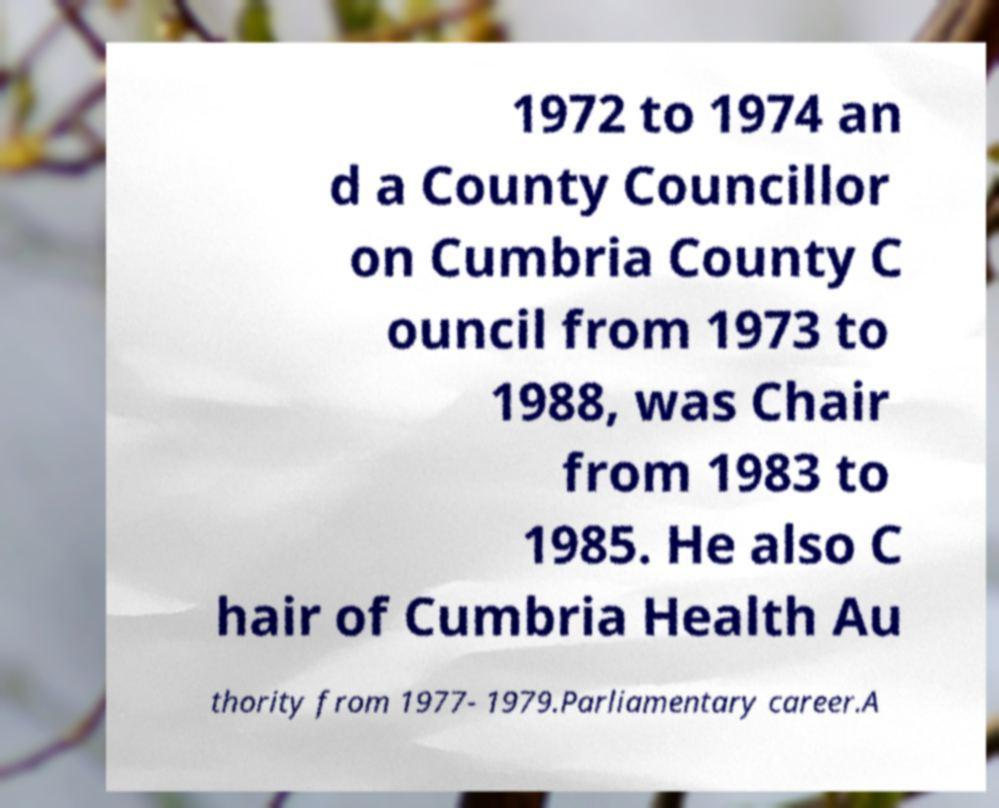Could you assist in decoding the text presented in this image and type it out clearly? 1972 to 1974 an d a County Councillor on Cumbria County C ouncil from 1973 to 1988, was Chair from 1983 to 1985. He also C hair of Cumbria Health Au thority from 1977- 1979.Parliamentary career.A 